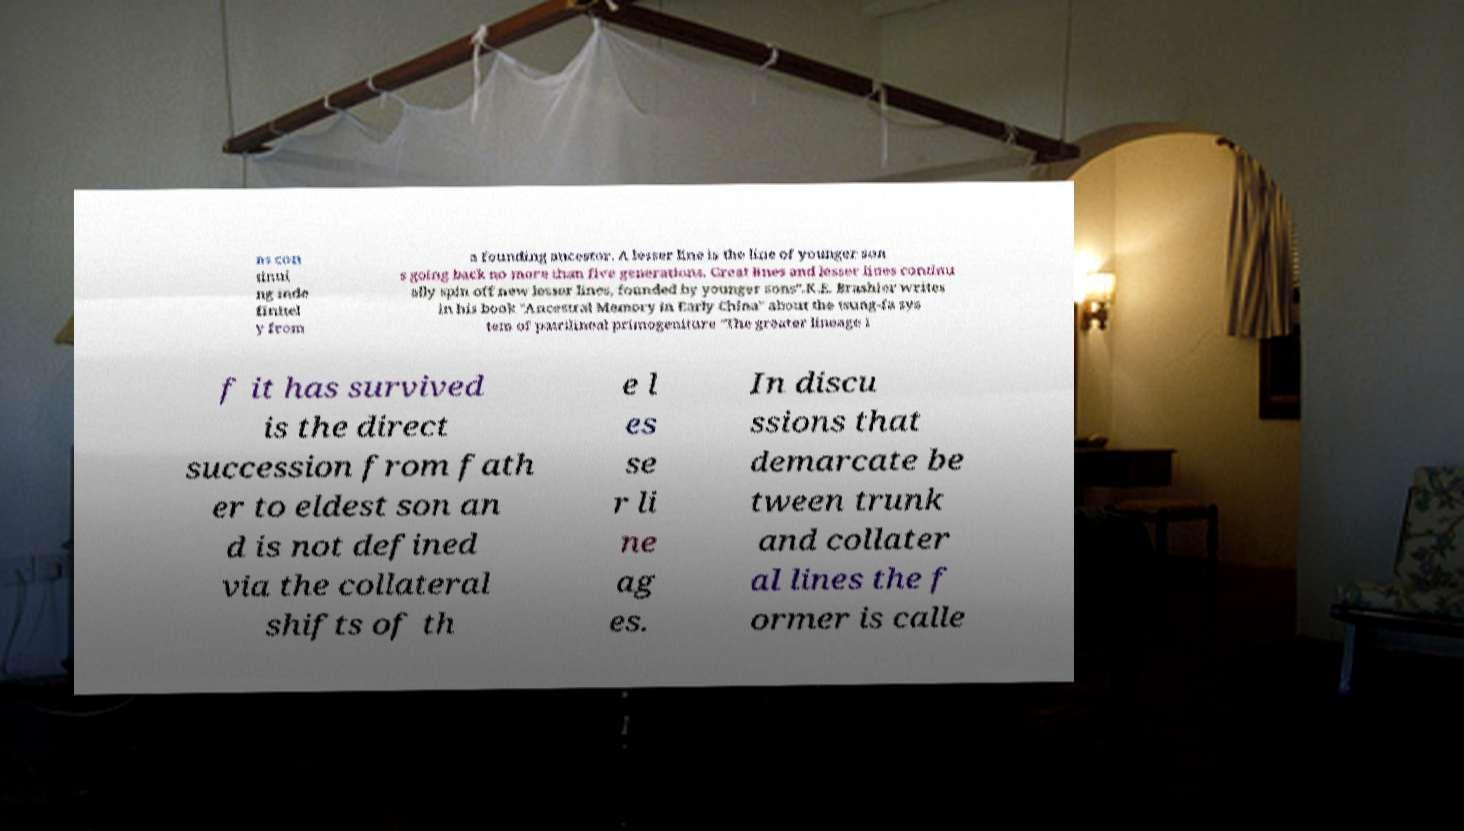Can you accurately transcribe the text from the provided image for me? ns con tinui ng inde finitel y from a founding ancestor. A lesser line is the line of younger son s going back no more than five generations. Great lines and lesser lines continu ally spin off new lesser lines, founded by younger sons".K.E. Brashier writes in his book "Ancestral Memory in Early China" about the tsung-fa sys tem of patrilineal primogeniture "The greater lineage i f it has survived is the direct succession from fath er to eldest son an d is not defined via the collateral shifts of th e l es se r li ne ag es. In discu ssions that demarcate be tween trunk and collater al lines the f ormer is calle 